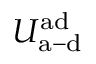<formula> <loc_0><loc_0><loc_500><loc_500>U _ { a - d } ^ { a d }</formula> 